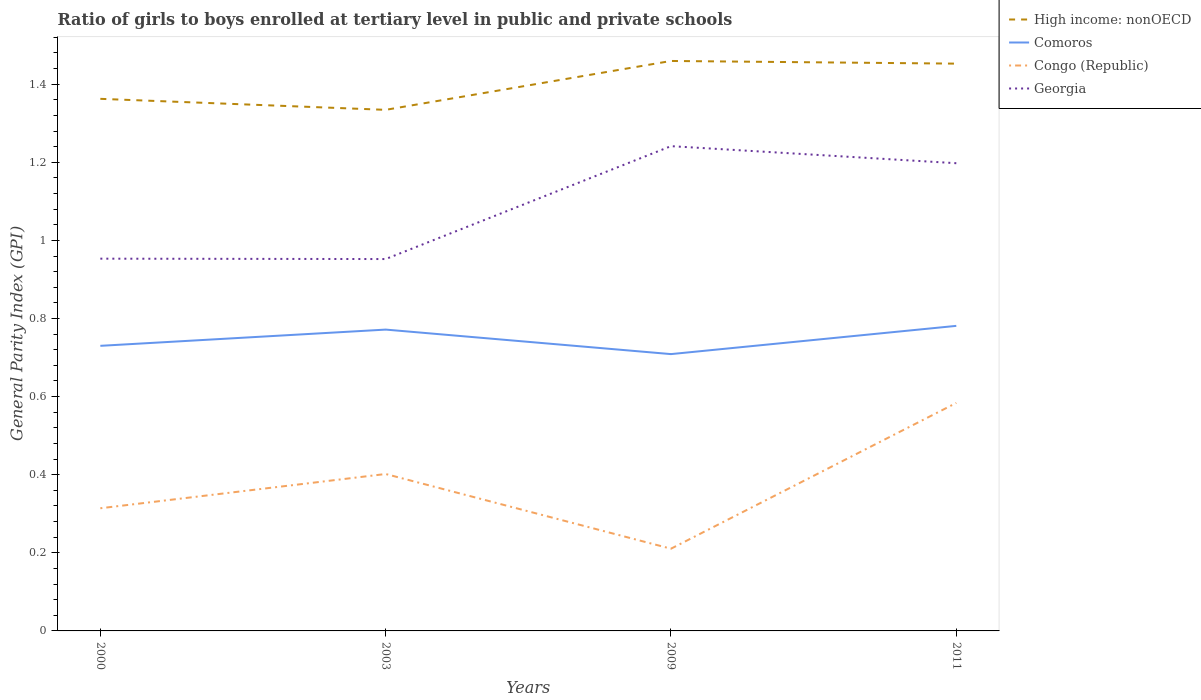How many different coloured lines are there?
Provide a short and direct response. 4. Does the line corresponding to Comoros intersect with the line corresponding to High income: nonOECD?
Your response must be concise. No. Is the number of lines equal to the number of legend labels?
Offer a terse response. Yes. Across all years, what is the maximum general parity index in Comoros?
Provide a succinct answer. 0.71. In which year was the general parity index in Comoros maximum?
Provide a short and direct response. 2009. What is the total general parity index in Georgia in the graph?
Keep it short and to the point. -0.25. What is the difference between the highest and the second highest general parity index in Comoros?
Ensure brevity in your answer.  0.07. What is the difference between the highest and the lowest general parity index in Georgia?
Ensure brevity in your answer.  2. How many lines are there?
Keep it short and to the point. 4. Are the values on the major ticks of Y-axis written in scientific E-notation?
Make the answer very short. No. Does the graph contain grids?
Make the answer very short. No. How many legend labels are there?
Ensure brevity in your answer.  4. How are the legend labels stacked?
Give a very brief answer. Vertical. What is the title of the graph?
Provide a succinct answer. Ratio of girls to boys enrolled at tertiary level in public and private schools. Does "Greenland" appear as one of the legend labels in the graph?
Ensure brevity in your answer.  No. What is the label or title of the Y-axis?
Give a very brief answer. General Parity Index (GPI). What is the General Parity Index (GPI) of High income: nonOECD in 2000?
Give a very brief answer. 1.36. What is the General Parity Index (GPI) in Comoros in 2000?
Make the answer very short. 0.73. What is the General Parity Index (GPI) in Congo (Republic) in 2000?
Ensure brevity in your answer.  0.31. What is the General Parity Index (GPI) in Georgia in 2000?
Give a very brief answer. 0.95. What is the General Parity Index (GPI) in High income: nonOECD in 2003?
Give a very brief answer. 1.33. What is the General Parity Index (GPI) of Comoros in 2003?
Your answer should be very brief. 0.77. What is the General Parity Index (GPI) in Congo (Republic) in 2003?
Your response must be concise. 0.4. What is the General Parity Index (GPI) in Georgia in 2003?
Offer a terse response. 0.95. What is the General Parity Index (GPI) in High income: nonOECD in 2009?
Make the answer very short. 1.46. What is the General Parity Index (GPI) in Comoros in 2009?
Your answer should be very brief. 0.71. What is the General Parity Index (GPI) of Congo (Republic) in 2009?
Offer a very short reply. 0.21. What is the General Parity Index (GPI) of Georgia in 2009?
Your response must be concise. 1.24. What is the General Parity Index (GPI) of High income: nonOECD in 2011?
Provide a short and direct response. 1.45. What is the General Parity Index (GPI) of Comoros in 2011?
Your answer should be compact. 0.78. What is the General Parity Index (GPI) in Congo (Republic) in 2011?
Offer a terse response. 0.58. What is the General Parity Index (GPI) in Georgia in 2011?
Offer a terse response. 1.2. Across all years, what is the maximum General Parity Index (GPI) in High income: nonOECD?
Ensure brevity in your answer.  1.46. Across all years, what is the maximum General Parity Index (GPI) of Comoros?
Offer a very short reply. 0.78. Across all years, what is the maximum General Parity Index (GPI) in Congo (Republic)?
Provide a succinct answer. 0.58. Across all years, what is the maximum General Parity Index (GPI) in Georgia?
Give a very brief answer. 1.24. Across all years, what is the minimum General Parity Index (GPI) in High income: nonOECD?
Offer a terse response. 1.33. Across all years, what is the minimum General Parity Index (GPI) in Comoros?
Ensure brevity in your answer.  0.71. Across all years, what is the minimum General Parity Index (GPI) of Congo (Republic)?
Your answer should be compact. 0.21. Across all years, what is the minimum General Parity Index (GPI) in Georgia?
Offer a very short reply. 0.95. What is the total General Parity Index (GPI) of High income: nonOECD in the graph?
Make the answer very short. 5.61. What is the total General Parity Index (GPI) of Comoros in the graph?
Make the answer very short. 2.99. What is the total General Parity Index (GPI) in Congo (Republic) in the graph?
Offer a very short reply. 1.51. What is the total General Parity Index (GPI) of Georgia in the graph?
Provide a succinct answer. 4.34. What is the difference between the General Parity Index (GPI) of High income: nonOECD in 2000 and that in 2003?
Provide a succinct answer. 0.03. What is the difference between the General Parity Index (GPI) of Comoros in 2000 and that in 2003?
Make the answer very short. -0.04. What is the difference between the General Parity Index (GPI) of Congo (Republic) in 2000 and that in 2003?
Offer a terse response. -0.09. What is the difference between the General Parity Index (GPI) of Georgia in 2000 and that in 2003?
Make the answer very short. 0. What is the difference between the General Parity Index (GPI) of High income: nonOECD in 2000 and that in 2009?
Your answer should be very brief. -0.1. What is the difference between the General Parity Index (GPI) of Comoros in 2000 and that in 2009?
Your answer should be compact. 0.02. What is the difference between the General Parity Index (GPI) of Congo (Republic) in 2000 and that in 2009?
Offer a very short reply. 0.1. What is the difference between the General Parity Index (GPI) in Georgia in 2000 and that in 2009?
Ensure brevity in your answer.  -0.29. What is the difference between the General Parity Index (GPI) of High income: nonOECD in 2000 and that in 2011?
Make the answer very short. -0.09. What is the difference between the General Parity Index (GPI) of Comoros in 2000 and that in 2011?
Your answer should be compact. -0.05. What is the difference between the General Parity Index (GPI) in Congo (Republic) in 2000 and that in 2011?
Give a very brief answer. -0.27. What is the difference between the General Parity Index (GPI) in Georgia in 2000 and that in 2011?
Your answer should be compact. -0.24. What is the difference between the General Parity Index (GPI) of High income: nonOECD in 2003 and that in 2009?
Make the answer very short. -0.13. What is the difference between the General Parity Index (GPI) in Comoros in 2003 and that in 2009?
Ensure brevity in your answer.  0.06. What is the difference between the General Parity Index (GPI) of Congo (Republic) in 2003 and that in 2009?
Ensure brevity in your answer.  0.19. What is the difference between the General Parity Index (GPI) in Georgia in 2003 and that in 2009?
Your answer should be compact. -0.29. What is the difference between the General Parity Index (GPI) in High income: nonOECD in 2003 and that in 2011?
Provide a short and direct response. -0.12. What is the difference between the General Parity Index (GPI) of Comoros in 2003 and that in 2011?
Keep it short and to the point. -0.01. What is the difference between the General Parity Index (GPI) of Congo (Republic) in 2003 and that in 2011?
Ensure brevity in your answer.  -0.18. What is the difference between the General Parity Index (GPI) of Georgia in 2003 and that in 2011?
Give a very brief answer. -0.25. What is the difference between the General Parity Index (GPI) in High income: nonOECD in 2009 and that in 2011?
Give a very brief answer. 0.01. What is the difference between the General Parity Index (GPI) of Comoros in 2009 and that in 2011?
Your response must be concise. -0.07. What is the difference between the General Parity Index (GPI) in Congo (Republic) in 2009 and that in 2011?
Provide a short and direct response. -0.37. What is the difference between the General Parity Index (GPI) of Georgia in 2009 and that in 2011?
Offer a terse response. 0.04. What is the difference between the General Parity Index (GPI) in High income: nonOECD in 2000 and the General Parity Index (GPI) in Comoros in 2003?
Ensure brevity in your answer.  0.59. What is the difference between the General Parity Index (GPI) of High income: nonOECD in 2000 and the General Parity Index (GPI) of Congo (Republic) in 2003?
Offer a very short reply. 0.96. What is the difference between the General Parity Index (GPI) of High income: nonOECD in 2000 and the General Parity Index (GPI) of Georgia in 2003?
Ensure brevity in your answer.  0.41. What is the difference between the General Parity Index (GPI) of Comoros in 2000 and the General Parity Index (GPI) of Congo (Republic) in 2003?
Your answer should be compact. 0.33. What is the difference between the General Parity Index (GPI) in Comoros in 2000 and the General Parity Index (GPI) in Georgia in 2003?
Provide a succinct answer. -0.22. What is the difference between the General Parity Index (GPI) of Congo (Republic) in 2000 and the General Parity Index (GPI) of Georgia in 2003?
Make the answer very short. -0.64. What is the difference between the General Parity Index (GPI) in High income: nonOECD in 2000 and the General Parity Index (GPI) in Comoros in 2009?
Provide a short and direct response. 0.65. What is the difference between the General Parity Index (GPI) in High income: nonOECD in 2000 and the General Parity Index (GPI) in Congo (Republic) in 2009?
Your response must be concise. 1.15. What is the difference between the General Parity Index (GPI) in High income: nonOECD in 2000 and the General Parity Index (GPI) in Georgia in 2009?
Make the answer very short. 0.12. What is the difference between the General Parity Index (GPI) in Comoros in 2000 and the General Parity Index (GPI) in Congo (Republic) in 2009?
Provide a short and direct response. 0.52. What is the difference between the General Parity Index (GPI) in Comoros in 2000 and the General Parity Index (GPI) in Georgia in 2009?
Provide a succinct answer. -0.51. What is the difference between the General Parity Index (GPI) in Congo (Republic) in 2000 and the General Parity Index (GPI) in Georgia in 2009?
Make the answer very short. -0.93. What is the difference between the General Parity Index (GPI) in High income: nonOECD in 2000 and the General Parity Index (GPI) in Comoros in 2011?
Give a very brief answer. 0.58. What is the difference between the General Parity Index (GPI) in High income: nonOECD in 2000 and the General Parity Index (GPI) in Congo (Republic) in 2011?
Keep it short and to the point. 0.78. What is the difference between the General Parity Index (GPI) of High income: nonOECD in 2000 and the General Parity Index (GPI) of Georgia in 2011?
Give a very brief answer. 0.16. What is the difference between the General Parity Index (GPI) in Comoros in 2000 and the General Parity Index (GPI) in Congo (Republic) in 2011?
Your answer should be compact. 0.15. What is the difference between the General Parity Index (GPI) in Comoros in 2000 and the General Parity Index (GPI) in Georgia in 2011?
Your response must be concise. -0.47. What is the difference between the General Parity Index (GPI) in Congo (Republic) in 2000 and the General Parity Index (GPI) in Georgia in 2011?
Provide a short and direct response. -0.88. What is the difference between the General Parity Index (GPI) of High income: nonOECD in 2003 and the General Parity Index (GPI) of Comoros in 2009?
Ensure brevity in your answer.  0.63. What is the difference between the General Parity Index (GPI) of High income: nonOECD in 2003 and the General Parity Index (GPI) of Congo (Republic) in 2009?
Make the answer very short. 1.12. What is the difference between the General Parity Index (GPI) in High income: nonOECD in 2003 and the General Parity Index (GPI) in Georgia in 2009?
Your answer should be very brief. 0.09. What is the difference between the General Parity Index (GPI) of Comoros in 2003 and the General Parity Index (GPI) of Congo (Republic) in 2009?
Give a very brief answer. 0.56. What is the difference between the General Parity Index (GPI) in Comoros in 2003 and the General Parity Index (GPI) in Georgia in 2009?
Provide a short and direct response. -0.47. What is the difference between the General Parity Index (GPI) of Congo (Republic) in 2003 and the General Parity Index (GPI) of Georgia in 2009?
Keep it short and to the point. -0.84. What is the difference between the General Parity Index (GPI) in High income: nonOECD in 2003 and the General Parity Index (GPI) in Comoros in 2011?
Ensure brevity in your answer.  0.55. What is the difference between the General Parity Index (GPI) of High income: nonOECD in 2003 and the General Parity Index (GPI) of Congo (Republic) in 2011?
Offer a very short reply. 0.75. What is the difference between the General Parity Index (GPI) in High income: nonOECD in 2003 and the General Parity Index (GPI) in Georgia in 2011?
Your answer should be compact. 0.14. What is the difference between the General Parity Index (GPI) of Comoros in 2003 and the General Parity Index (GPI) of Congo (Republic) in 2011?
Your answer should be compact. 0.19. What is the difference between the General Parity Index (GPI) in Comoros in 2003 and the General Parity Index (GPI) in Georgia in 2011?
Make the answer very short. -0.43. What is the difference between the General Parity Index (GPI) in Congo (Republic) in 2003 and the General Parity Index (GPI) in Georgia in 2011?
Ensure brevity in your answer.  -0.8. What is the difference between the General Parity Index (GPI) in High income: nonOECD in 2009 and the General Parity Index (GPI) in Comoros in 2011?
Your response must be concise. 0.68. What is the difference between the General Parity Index (GPI) in High income: nonOECD in 2009 and the General Parity Index (GPI) in Congo (Republic) in 2011?
Provide a succinct answer. 0.88. What is the difference between the General Parity Index (GPI) in High income: nonOECD in 2009 and the General Parity Index (GPI) in Georgia in 2011?
Your answer should be very brief. 0.26. What is the difference between the General Parity Index (GPI) of Comoros in 2009 and the General Parity Index (GPI) of Georgia in 2011?
Your response must be concise. -0.49. What is the difference between the General Parity Index (GPI) in Congo (Republic) in 2009 and the General Parity Index (GPI) in Georgia in 2011?
Offer a terse response. -0.99. What is the average General Parity Index (GPI) in High income: nonOECD per year?
Your response must be concise. 1.4. What is the average General Parity Index (GPI) of Comoros per year?
Ensure brevity in your answer.  0.75. What is the average General Parity Index (GPI) in Congo (Republic) per year?
Provide a short and direct response. 0.38. What is the average General Parity Index (GPI) of Georgia per year?
Ensure brevity in your answer.  1.09. In the year 2000, what is the difference between the General Parity Index (GPI) of High income: nonOECD and General Parity Index (GPI) of Comoros?
Your answer should be very brief. 0.63. In the year 2000, what is the difference between the General Parity Index (GPI) in High income: nonOECD and General Parity Index (GPI) in Congo (Republic)?
Make the answer very short. 1.05. In the year 2000, what is the difference between the General Parity Index (GPI) in High income: nonOECD and General Parity Index (GPI) in Georgia?
Keep it short and to the point. 0.41. In the year 2000, what is the difference between the General Parity Index (GPI) in Comoros and General Parity Index (GPI) in Congo (Republic)?
Your response must be concise. 0.42. In the year 2000, what is the difference between the General Parity Index (GPI) in Comoros and General Parity Index (GPI) in Georgia?
Keep it short and to the point. -0.22. In the year 2000, what is the difference between the General Parity Index (GPI) of Congo (Republic) and General Parity Index (GPI) of Georgia?
Your response must be concise. -0.64. In the year 2003, what is the difference between the General Parity Index (GPI) of High income: nonOECD and General Parity Index (GPI) of Comoros?
Provide a short and direct response. 0.56. In the year 2003, what is the difference between the General Parity Index (GPI) in High income: nonOECD and General Parity Index (GPI) in Congo (Republic)?
Provide a succinct answer. 0.93. In the year 2003, what is the difference between the General Parity Index (GPI) in High income: nonOECD and General Parity Index (GPI) in Georgia?
Provide a short and direct response. 0.38. In the year 2003, what is the difference between the General Parity Index (GPI) in Comoros and General Parity Index (GPI) in Congo (Republic)?
Keep it short and to the point. 0.37. In the year 2003, what is the difference between the General Parity Index (GPI) in Comoros and General Parity Index (GPI) in Georgia?
Ensure brevity in your answer.  -0.18. In the year 2003, what is the difference between the General Parity Index (GPI) of Congo (Republic) and General Parity Index (GPI) of Georgia?
Your answer should be compact. -0.55. In the year 2009, what is the difference between the General Parity Index (GPI) of High income: nonOECD and General Parity Index (GPI) of Comoros?
Your response must be concise. 0.75. In the year 2009, what is the difference between the General Parity Index (GPI) in High income: nonOECD and General Parity Index (GPI) in Congo (Republic)?
Make the answer very short. 1.25. In the year 2009, what is the difference between the General Parity Index (GPI) in High income: nonOECD and General Parity Index (GPI) in Georgia?
Provide a short and direct response. 0.22. In the year 2009, what is the difference between the General Parity Index (GPI) in Comoros and General Parity Index (GPI) in Congo (Republic)?
Ensure brevity in your answer.  0.5. In the year 2009, what is the difference between the General Parity Index (GPI) in Comoros and General Parity Index (GPI) in Georgia?
Your answer should be very brief. -0.53. In the year 2009, what is the difference between the General Parity Index (GPI) of Congo (Republic) and General Parity Index (GPI) of Georgia?
Provide a succinct answer. -1.03. In the year 2011, what is the difference between the General Parity Index (GPI) in High income: nonOECD and General Parity Index (GPI) in Comoros?
Your answer should be very brief. 0.67. In the year 2011, what is the difference between the General Parity Index (GPI) in High income: nonOECD and General Parity Index (GPI) in Congo (Republic)?
Make the answer very short. 0.87. In the year 2011, what is the difference between the General Parity Index (GPI) of High income: nonOECD and General Parity Index (GPI) of Georgia?
Provide a succinct answer. 0.26. In the year 2011, what is the difference between the General Parity Index (GPI) of Comoros and General Parity Index (GPI) of Congo (Republic)?
Give a very brief answer. 0.2. In the year 2011, what is the difference between the General Parity Index (GPI) in Comoros and General Parity Index (GPI) in Georgia?
Make the answer very short. -0.42. In the year 2011, what is the difference between the General Parity Index (GPI) of Congo (Republic) and General Parity Index (GPI) of Georgia?
Provide a succinct answer. -0.61. What is the ratio of the General Parity Index (GPI) of High income: nonOECD in 2000 to that in 2003?
Offer a terse response. 1.02. What is the ratio of the General Parity Index (GPI) of Comoros in 2000 to that in 2003?
Provide a succinct answer. 0.95. What is the ratio of the General Parity Index (GPI) of Congo (Republic) in 2000 to that in 2003?
Your response must be concise. 0.78. What is the ratio of the General Parity Index (GPI) of Georgia in 2000 to that in 2003?
Provide a succinct answer. 1. What is the ratio of the General Parity Index (GPI) of High income: nonOECD in 2000 to that in 2009?
Make the answer very short. 0.93. What is the ratio of the General Parity Index (GPI) of Comoros in 2000 to that in 2009?
Keep it short and to the point. 1.03. What is the ratio of the General Parity Index (GPI) of Congo (Republic) in 2000 to that in 2009?
Provide a short and direct response. 1.49. What is the ratio of the General Parity Index (GPI) of Georgia in 2000 to that in 2009?
Keep it short and to the point. 0.77. What is the ratio of the General Parity Index (GPI) of High income: nonOECD in 2000 to that in 2011?
Give a very brief answer. 0.94. What is the ratio of the General Parity Index (GPI) in Comoros in 2000 to that in 2011?
Make the answer very short. 0.93. What is the ratio of the General Parity Index (GPI) in Congo (Republic) in 2000 to that in 2011?
Keep it short and to the point. 0.54. What is the ratio of the General Parity Index (GPI) in Georgia in 2000 to that in 2011?
Give a very brief answer. 0.8. What is the ratio of the General Parity Index (GPI) of High income: nonOECD in 2003 to that in 2009?
Provide a succinct answer. 0.91. What is the ratio of the General Parity Index (GPI) of Comoros in 2003 to that in 2009?
Offer a terse response. 1.09. What is the ratio of the General Parity Index (GPI) of Congo (Republic) in 2003 to that in 2009?
Give a very brief answer. 1.91. What is the ratio of the General Parity Index (GPI) in Georgia in 2003 to that in 2009?
Your answer should be compact. 0.77. What is the ratio of the General Parity Index (GPI) of High income: nonOECD in 2003 to that in 2011?
Your answer should be very brief. 0.92. What is the ratio of the General Parity Index (GPI) of Congo (Republic) in 2003 to that in 2011?
Provide a short and direct response. 0.69. What is the ratio of the General Parity Index (GPI) of Georgia in 2003 to that in 2011?
Your response must be concise. 0.8. What is the ratio of the General Parity Index (GPI) in Comoros in 2009 to that in 2011?
Make the answer very short. 0.91. What is the ratio of the General Parity Index (GPI) in Congo (Republic) in 2009 to that in 2011?
Your answer should be very brief. 0.36. What is the ratio of the General Parity Index (GPI) in Georgia in 2009 to that in 2011?
Provide a short and direct response. 1.04. What is the difference between the highest and the second highest General Parity Index (GPI) of High income: nonOECD?
Offer a terse response. 0.01. What is the difference between the highest and the second highest General Parity Index (GPI) of Comoros?
Offer a very short reply. 0.01. What is the difference between the highest and the second highest General Parity Index (GPI) of Congo (Republic)?
Make the answer very short. 0.18. What is the difference between the highest and the second highest General Parity Index (GPI) of Georgia?
Provide a short and direct response. 0.04. What is the difference between the highest and the lowest General Parity Index (GPI) of High income: nonOECD?
Offer a terse response. 0.13. What is the difference between the highest and the lowest General Parity Index (GPI) of Comoros?
Offer a very short reply. 0.07. What is the difference between the highest and the lowest General Parity Index (GPI) in Congo (Republic)?
Make the answer very short. 0.37. What is the difference between the highest and the lowest General Parity Index (GPI) of Georgia?
Offer a very short reply. 0.29. 